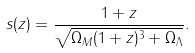<formula> <loc_0><loc_0><loc_500><loc_500>s ( z ) = \frac { 1 + z } { \sqrt { \Omega _ { M } ( 1 + z ) ^ { 3 } + \Omega _ { \Lambda } } } .</formula> 